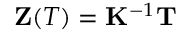<formula> <loc_0><loc_0><loc_500><loc_500>\mathbf Z ( T ) = \mathbf K ^ { - 1 } \mathbf T</formula> 